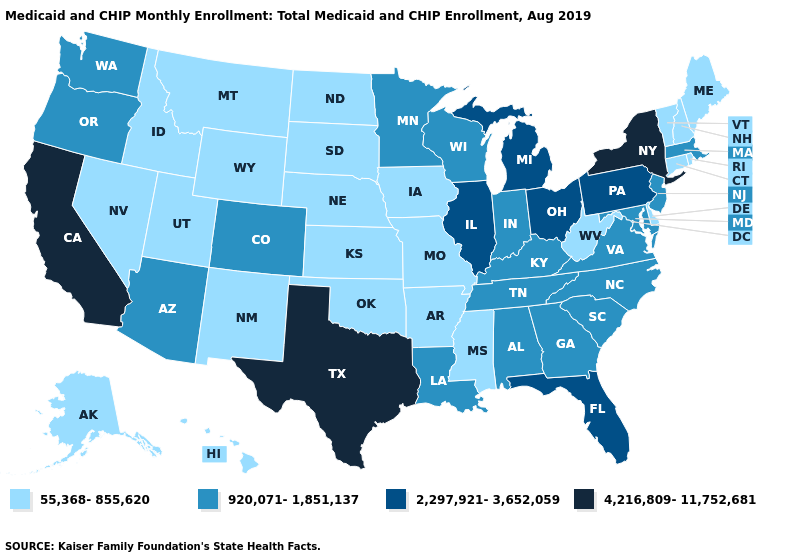Among the states that border Rhode Island , does Connecticut have the highest value?
Short answer required. No. Which states hav the highest value in the South?
Give a very brief answer. Texas. Does Texas have the highest value in the South?
Answer briefly. Yes. Name the states that have a value in the range 55,368-855,620?
Be succinct. Alaska, Arkansas, Connecticut, Delaware, Hawaii, Idaho, Iowa, Kansas, Maine, Mississippi, Missouri, Montana, Nebraska, Nevada, New Hampshire, New Mexico, North Dakota, Oklahoma, Rhode Island, South Dakota, Utah, Vermont, West Virginia, Wyoming. Name the states that have a value in the range 4,216,809-11,752,681?
Give a very brief answer. California, New York, Texas. What is the lowest value in the West?
Quick response, please. 55,368-855,620. Does Oklahoma have the lowest value in the South?
Concise answer only. Yes. What is the lowest value in states that border Louisiana?
Answer briefly. 55,368-855,620. Among the states that border Arizona , which have the lowest value?
Give a very brief answer. Nevada, New Mexico, Utah. Among the states that border Illinois , which have the lowest value?
Give a very brief answer. Iowa, Missouri. Name the states that have a value in the range 920,071-1,851,137?
Keep it brief. Alabama, Arizona, Colorado, Georgia, Indiana, Kentucky, Louisiana, Maryland, Massachusetts, Minnesota, New Jersey, North Carolina, Oregon, South Carolina, Tennessee, Virginia, Washington, Wisconsin. Name the states that have a value in the range 2,297,921-3,652,059?
Quick response, please. Florida, Illinois, Michigan, Ohio, Pennsylvania. Name the states that have a value in the range 2,297,921-3,652,059?
Be succinct. Florida, Illinois, Michigan, Ohio, Pennsylvania. What is the highest value in the USA?
Write a very short answer. 4,216,809-11,752,681. Name the states that have a value in the range 4,216,809-11,752,681?
Be succinct. California, New York, Texas. 